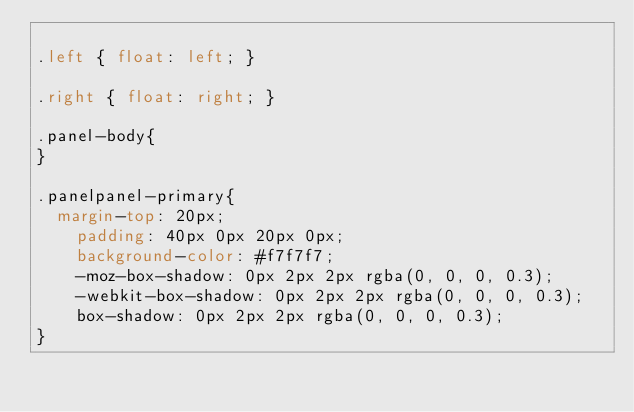<code> <loc_0><loc_0><loc_500><loc_500><_CSS_>
.left { float: left; }

.right { float: right; }

.panel-body{
}

.panelpanel-primary{
	margin-top: 20px;
    padding: 40px 0px 20px 0px;
    background-color: #f7f7f7;
    -moz-box-shadow: 0px 2px 2px rgba(0, 0, 0, 0.3);
    -webkit-box-shadow: 0px 2px 2px rgba(0, 0, 0, 0.3);
    box-shadow: 0px 2px 2px rgba(0, 0, 0, 0.3);
}</code> 